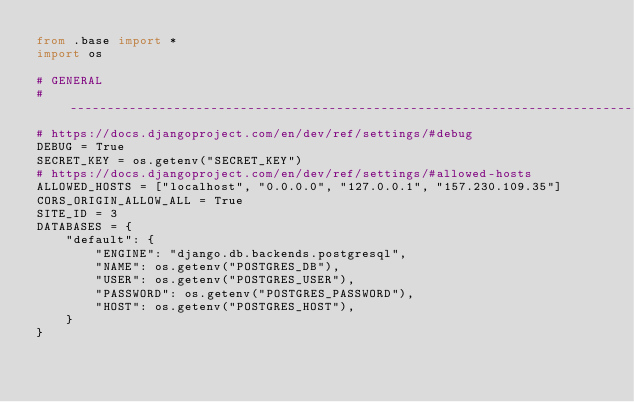Convert code to text. <code><loc_0><loc_0><loc_500><loc_500><_Python_>from .base import *
import os

# GENERAL
# ------------------------------------------------------------------------------
# https://docs.djangoproject.com/en/dev/ref/settings/#debug
DEBUG = True
SECRET_KEY = os.getenv("SECRET_KEY")
# https://docs.djangoproject.com/en/dev/ref/settings/#allowed-hosts
ALLOWED_HOSTS = ["localhost", "0.0.0.0", "127.0.0.1", "157.230.109.35"]
CORS_ORIGIN_ALLOW_ALL = True
SITE_ID = 3
DATABASES = {
    "default": {
        "ENGINE": "django.db.backends.postgresql",
        "NAME": os.getenv("POSTGRES_DB"),
        "USER": os.getenv("POSTGRES_USER"),
        "PASSWORD": os.getenv("POSTGRES_PASSWORD"),
        "HOST": os.getenv("POSTGRES_HOST"),
    }
}
</code> 